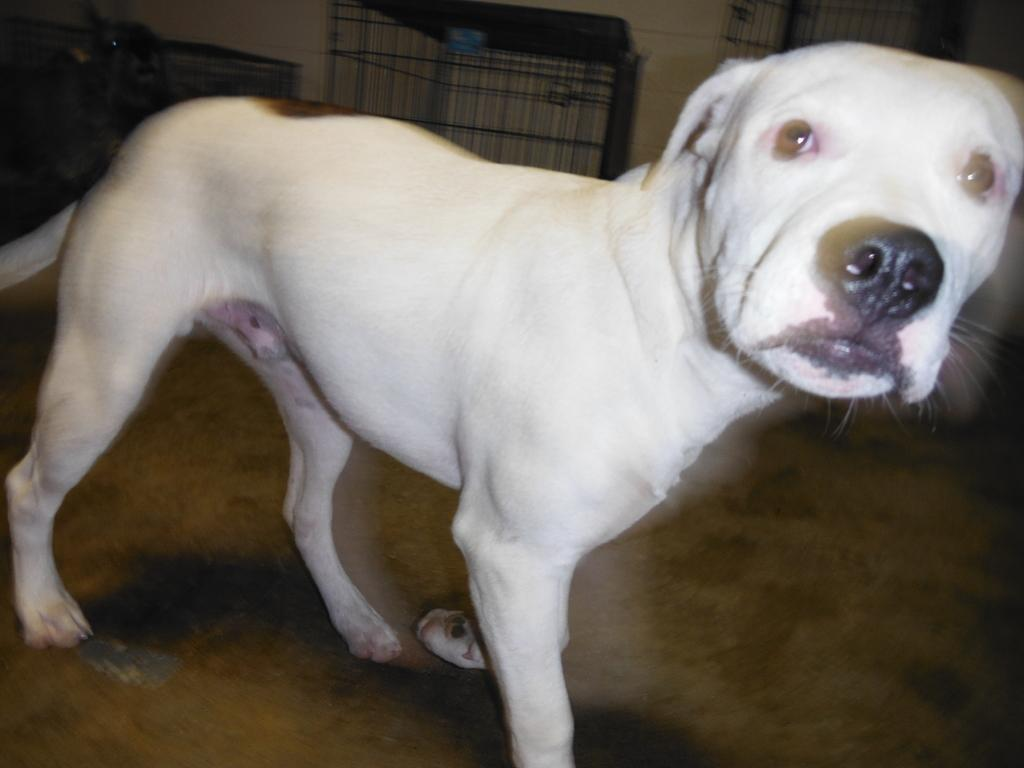What type of animal is in the image? There is a dog in the image. Can you describe the color of the dog? The dog is white. What structure is visible at the top of the image? There is a cage at the top of the image. What type of wave can be seen crashing on the shore in the image? There is no wave or shore present in the image; it features a dog and a cage. 